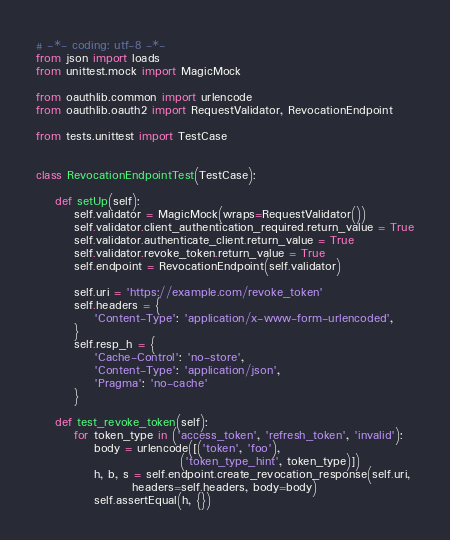Convert code to text. <code><loc_0><loc_0><loc_500><loc_500><_Python_># -*- coding: utf-8 -*-
from json import loads
from unittest.mock import MagicMock

from oauthlib.common import urlencode
from oauthlib.oauth2 import RequestValidator, RevocationEndpoint

from tests.unittest import TestCase


class RevocationEndpointTest(TestCase):

    def setUp(self):
        self.validator = MagicMock(wraps=RequestValidator())
        self.validator.client_authentication_required.return_value = True
        self.validator.authenticate_client.return_value = True
        self.validator.revoke_token.return_value = True
        self.endpoint = RevocationEndpoint(self.validator)

        self.uri = 'https://example.com/revoke_token'
        self.headers = {
            'Content-Type': 'application/x-www-form-urlencoded',
        }
        self.resp_h = {
            'Cache-Control': 'no-store',
            'Content-Type': 'application/json',
            'Pragma': 'no-cache'
        }

    def test_revoke_token(self):
        for token_type in ('access_token', 'refresh_token', 'invalid'):
            body = urlencode([('token', 'foo'),
                              ('token_type_hint', token_type)])
            h, b, s = self.endpoint.create_revocation_response(self.uri,
                    headers=self.headers, body=body)
            self.assertEqual(h, {})</code> 